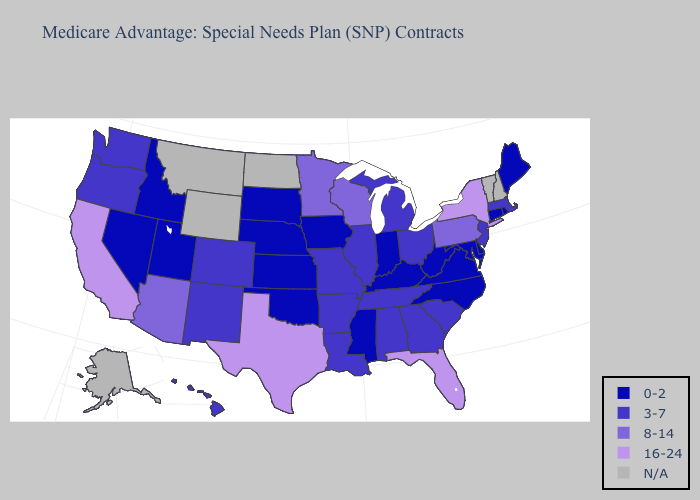Name the states that have a value in the range 0-2?
Answer briefly. Connecticut, Delaware, Iowa, Idaho, Indiana, Kansas, Kentucky, Maryland, Maine, Mississippi, North Carolina, Nebraska, Nevada, Oklahoma, Rhode Island, South Dakota, Utah, Virginia, West Virginia. What is the highest value in the MidWest ?
Answer briefly. 8-14. What is the lowest value in states that border Minnesota?
Write a very short answer. 0-2. Name the states that have a value in the range N/A?
Answer briefly. Alaska, Montana, North Dakota, New Hampshire, Vermont, Wyoming. What is the lowest value in the West?
Quick response, please. 0-2. Name the states that have a value in the range N/A?
Concise answer only. Alaska, Montana, North Dakota, New Hampshire, Vermont, Wyoming. Name the states that have a value in the range N/A?
Give a very brief answer. Alaska, Montana, North Dakota, New Hampshire, Vermont, Wyoming. Does California have the highest value in the USA?
Write a very short answer. Yes. What is the value of Georgia?
Keep it brief. 3-7. Which states have the lowest value in the West?
Quick response, please. Idaho, Nevada, Utah. What is the lowest value in states that border Oklahoma?
Keep it brief. 0-2. Does South Dakota have the highest value in the USA?
Be succinct. No. Name the states that have a value in the range 0-2?
Give a very brief answer. Connecticut, Delaware, Iowa, Idaho, Indiana, Kansas, Kentucky, Maryland, Maine, Mississippi, North Carolina, Nebraska, Nevada, Oklahoma, Rhode Island, South Dakota, Utah, Virginia, West Virginia. Among the states that border Idaho , which have the lowest value?
Concise answer only. Nevada, Utah. Does Oklahoma have the lowest value in the USA?
Short answer required. Yes. 